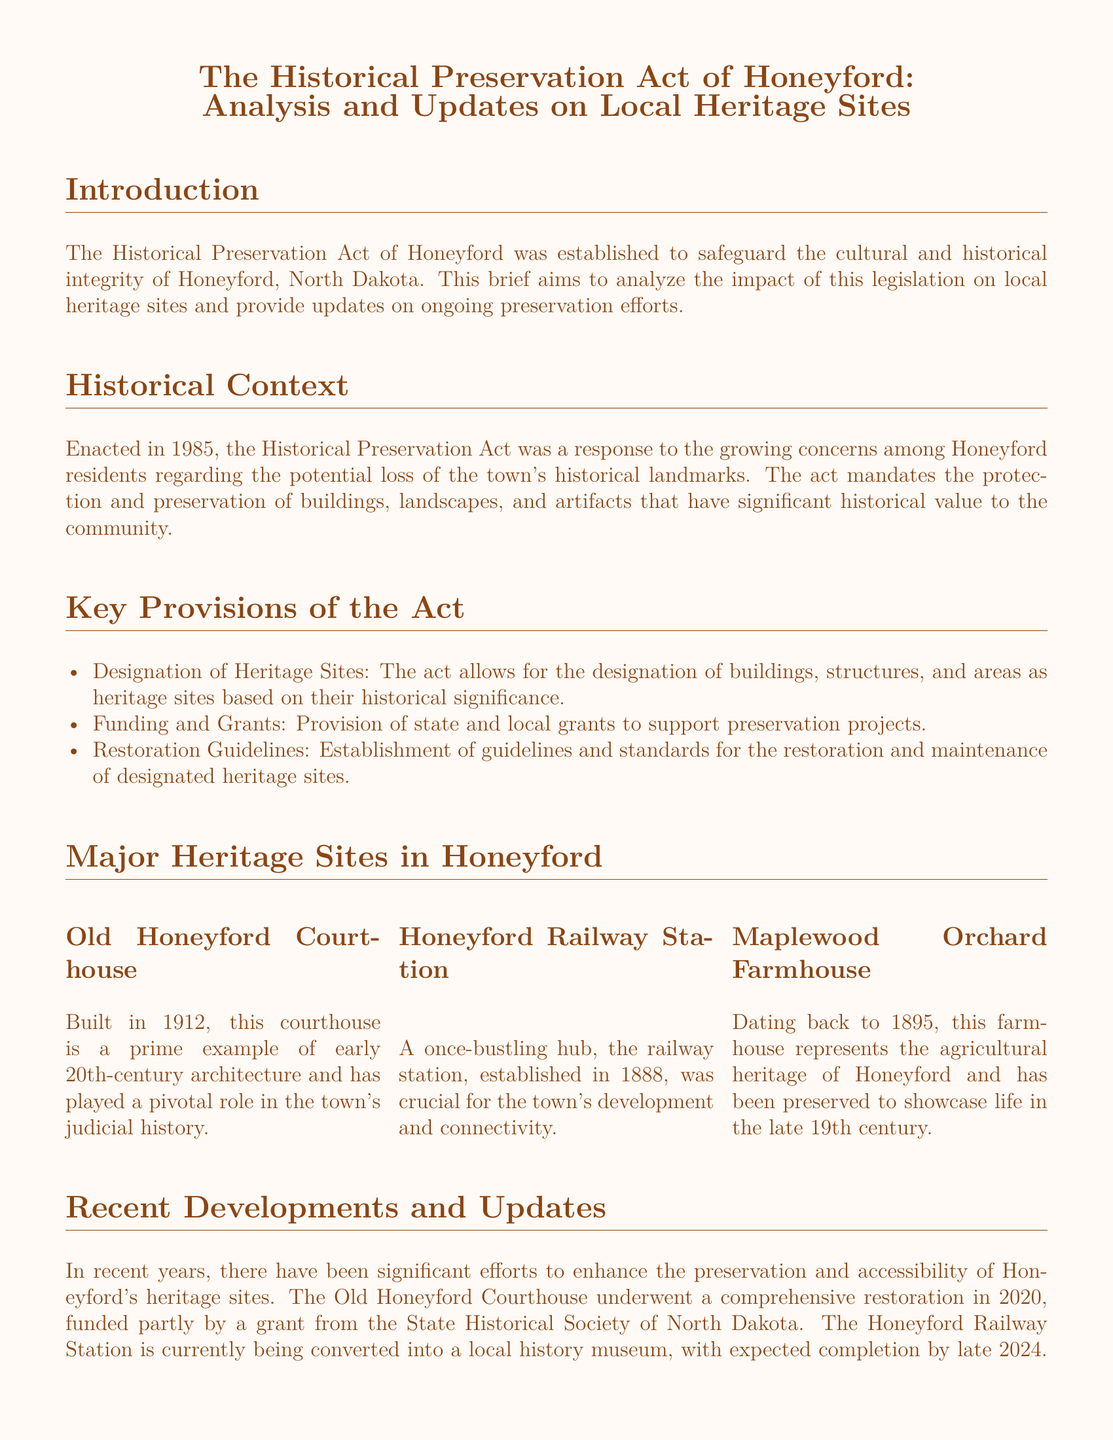What year was the Historical Preservation Act enacted? The year the Historical Preservation Act was enacted is mentioned in the context section of the document.
Answer: 1985 What is one major heritage site in Honeyford? The document lists major heritage sites; one example is specified in the relevant section.
Answer: Old Honeyford Courthouse What architectural style is the Old Honeyford Courthouse known for? The document describes the Old Honeyford Courthouse and its significance in terms of architectural style.
Answer: Early 20th-century When is the expected completion date for the Railway Station museum? The document provides information about the timeline for the conversion of the Honeyford Railway Station into a museum.
Answer: Late 2024 What type of programs has Maplewood Orchard Farmhouse introduced? The document mentions specific initiatives taken by Maplewood Orchard Farmhouse to engage the community with local history.
Answer: Guided tours and educational programs Who provided a grant for the restoration of the Old Honeyford Courthouse? The document states the source of funding for the courthouse restoration project.
Answer: State Historical Society of North Dakota What main concern led to the establishment of the Historical Preservation Act? The introduction section discusses why the act was created, highlighting specific community concerns.
Answer: Potential loss of historical landmarks What are the restoration guidelines meant to establish? The document outlines the purpose of the restoration guidelines included in the act.
Answer: Guidelines and standards for the restoration and maintenance 